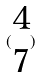<formula> <loc_0><loc_0><loc_500><loc_500>( \begin{matrix} 4 \\ 7 \end{matrix} )</formula> 